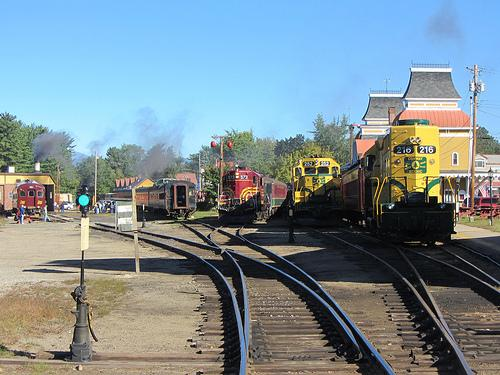Count the total number of trees present in the image. There are a total of four trees in the image. Using formal academic language, describe the setting of this image. The scene depicts a railway station encompassing numerous trains of varying colors, a series of parallel train tracks, verdant trees adjacent to the station, patches of grass, and a cloudless blue sky overhead with an adjacent utility pole. Perform a sentiment analysis of the image. Is it positive, neutral, or negative? Why? Positive - The vibrant colors, a clear day with blue sky and green trees, and the presence of trains for transportation create an optimistic and lively atmosphere. Examine the tree in the image. Describe its main characteristics, including its position and size. Tree 4: (295, 110), (52, 52) Provide a brief description of the area surrounding the train tracks. The train tracks are surrounded by green and brown grass patches, tall trees with green leaves, and a distant building next to a utility pole. What color is the traffic light on the pole, and where is it located? The traffic light is green and is located at position (X, Y): (69, 182) with Width: 30 and Height: 30. In simple words, what are the main elements found in the image? Trains, train tracks, trees, grass, sky, telephone pole, and people. How many people are present in front of a train, and what are they wearing? There are two people in front of a train, both wearing white shirts. Analyze the image quality of the train and rail system. Is it modern or traditional based on the image's information? Based on the information present in the image, the train and rail system appears to be traditional, with an old-fashioned train sign and wooden-track components. What colors are the three trains side by side? The colors of the three trains side by side are red, yellow, and green. 